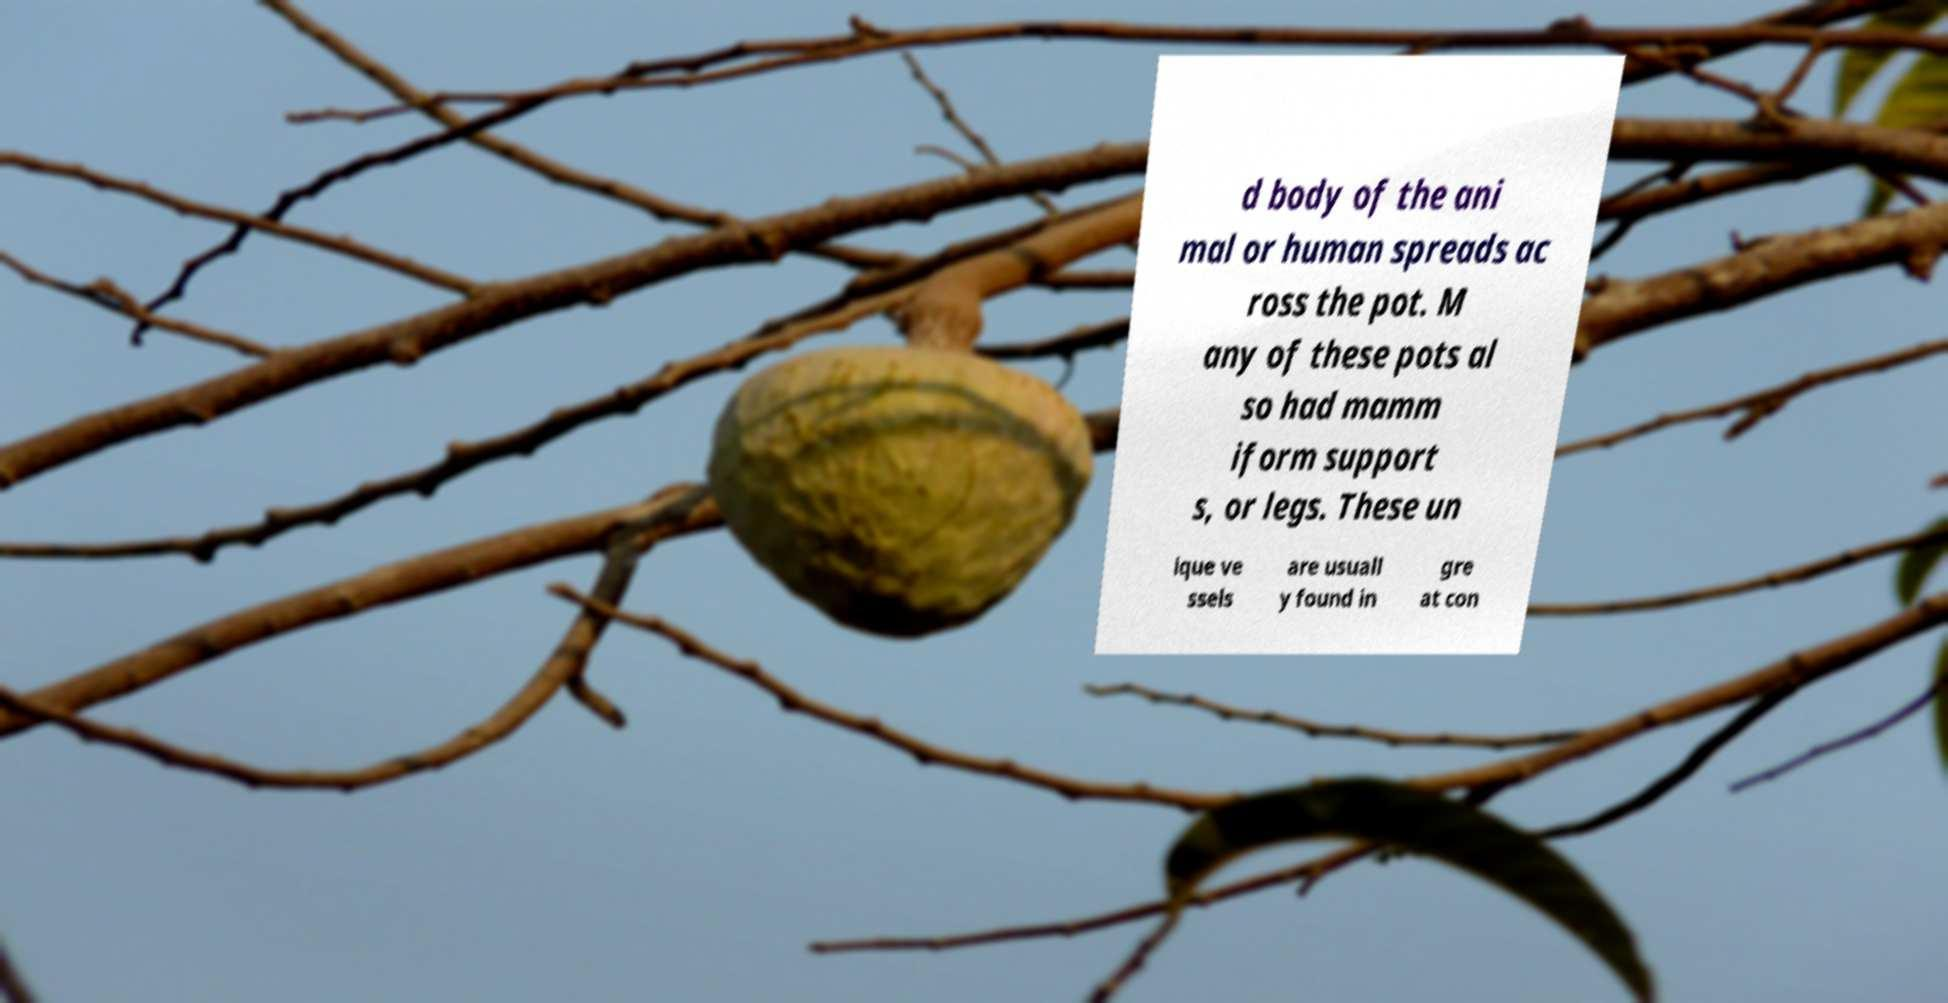Please read and relay the text visible in this image. What does it say? d body of the ani mal or human spreads ac ross the pot. M any of these pots al so had mamm iform support s, or legs. These un ique ve ssels are usuall y found in gre at con 